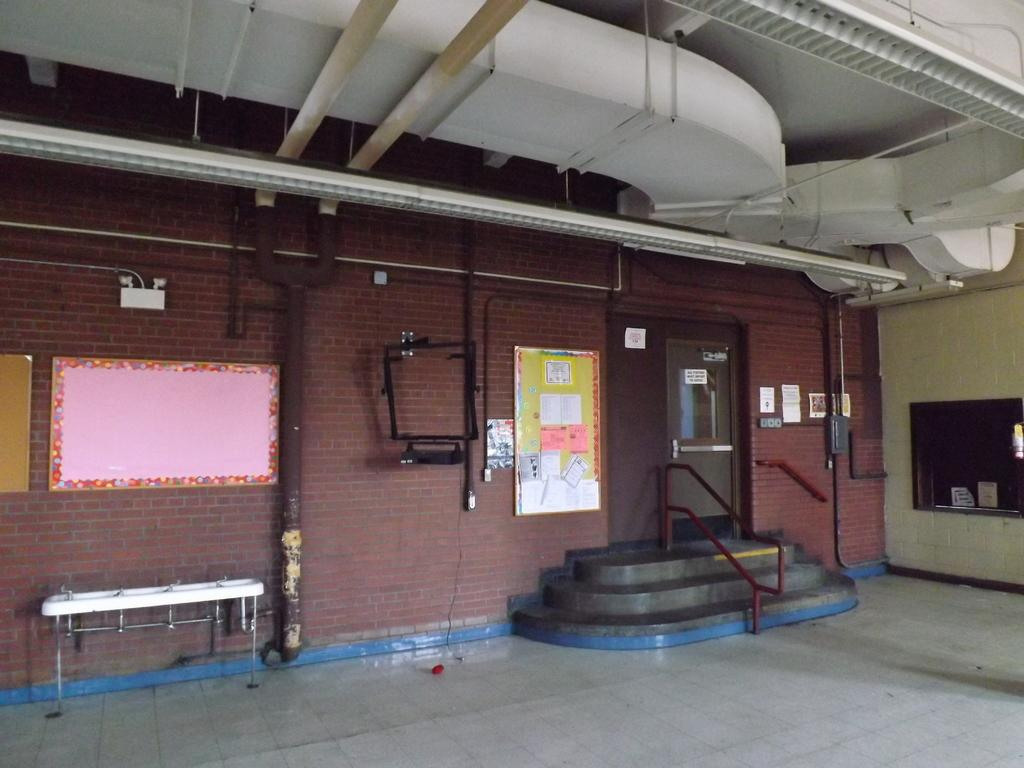Where was the image taken? The image is taken outside a building. What can be seen on the wall in the image? There are boards and notices on the wall in the image. What architectural features are present in the image? There is a door and a staircase in the image. What can be used for washing purposes in the image? There are sinks in the image. What type of lunch is being served in the image? There is no lunch present in the image; it only shows a building exterior with boards, notices, a door, a staircase, and sinks. 